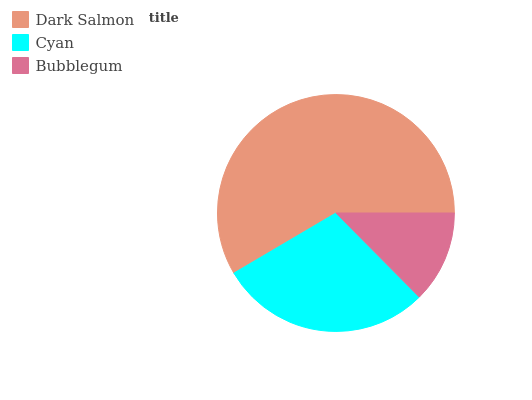Is Bubblegum the minimum?
Answer yes or no. Yes. Is Dark Salmon the maximum?
Answer yes or no. Yes. Is Cyan the minimum?
Answer yes or no. No. Is Cyan the maximum?
Answer yes or no. No. Is Dark Salmon greater than Cyan?
Answer yes or no. Yes. Is Cyan less than Dark Salmon?
Answer yes or no. Yes. Is Cyan greater than Dark Salmon?
Answer yes or no. No. Is Dark Salmon less than Cyan?
Answer yes or no. No. Is Cyan the high median?
Answer yes or no. Yes. Is Cyan the low median?
Answer yes or no. Yes. Is Dark Salmon the high median?
Answer yes or no. No. Is Dark Salmon the low median?
Answer yes or no. No. 